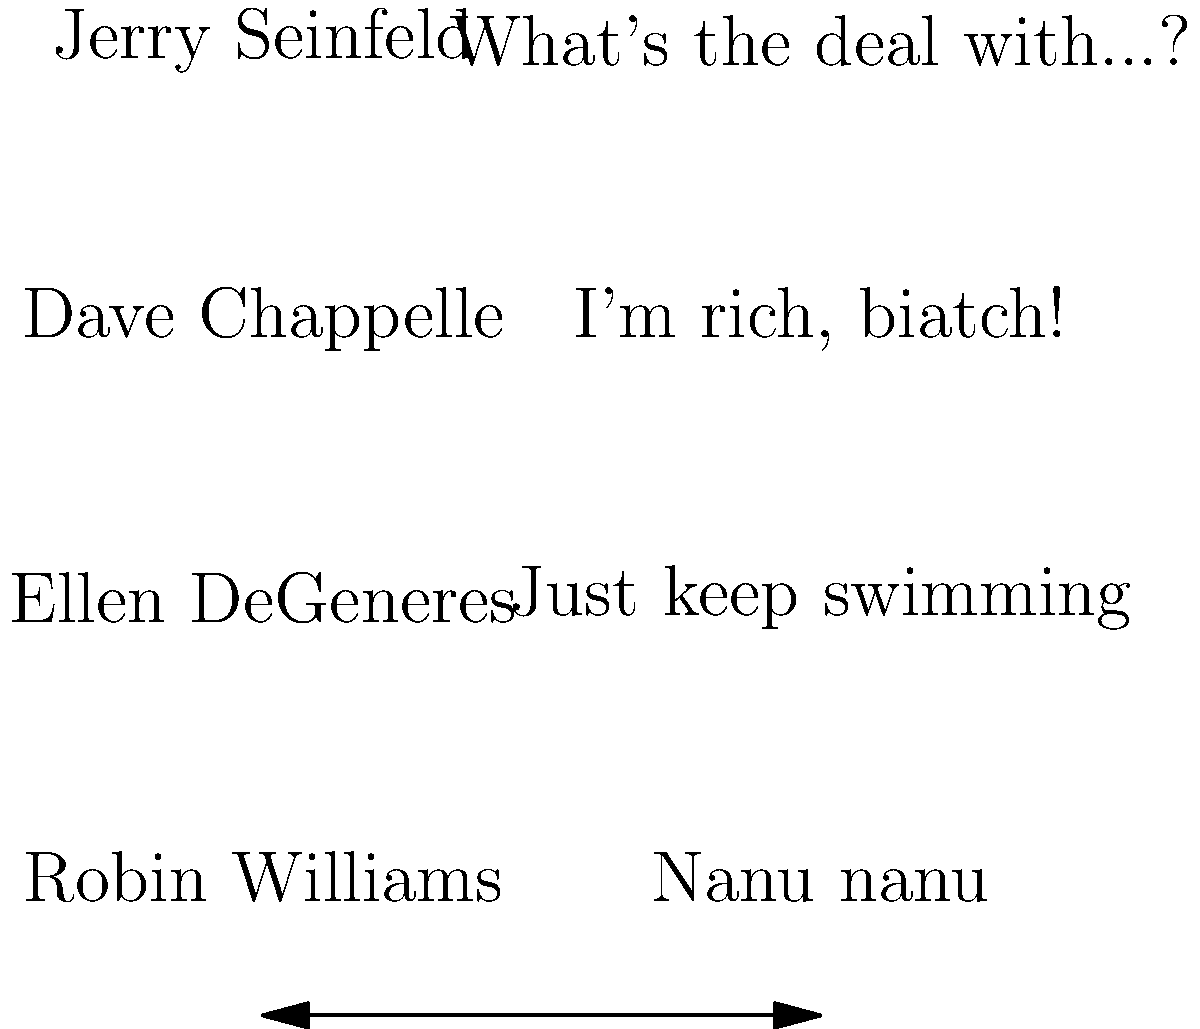Match the comedians to their signature catchphrases or punchlines. Which comedian is associated with the phrase "Just keep swimming"? To answer this question, let's analyze each comedian and their associated catchphrase:

1. Jerry Seinfeld: Known for observational humor, often starting with "What's the deal with...?"
2. Dave Chappelle: Often used "I'm rich, biatch!" in his comedy sketches.
3. Ellen DeGeneres: While not her catchphrase, "Just keep swimming" is associated with her voice role as Dory in "Finding Nemo."
4. Robin Williams: Famous for saying "Nanu nanu" as Mork in "Mork & Mindy."

The phrase "Just keep swimming" is from the animated film "Finding Nemo," where Ellen DeGeneres voiced the character Dory. While it's not strictly a stand-up catchphrase, it's strongly associated with Ellen due to her memorable performance and the phrase's popularity.

As a stand-up comic looking to integrate more music into your routine, understanding these associations can help you create musical parodies or references to well-known comedic phrases, potentially incorporating them into song lyrics or musical bits.
Answer: Ellen DeGeneres 